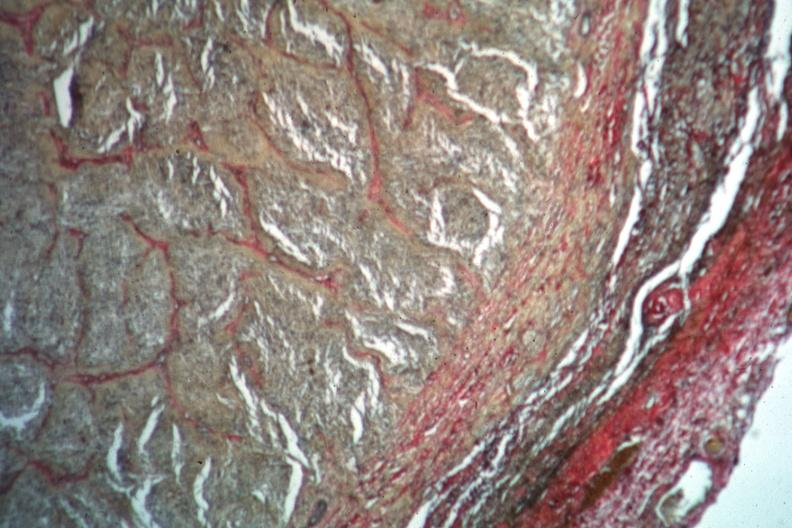s eye present?
Answer the question using a single word or phrase. Yes 